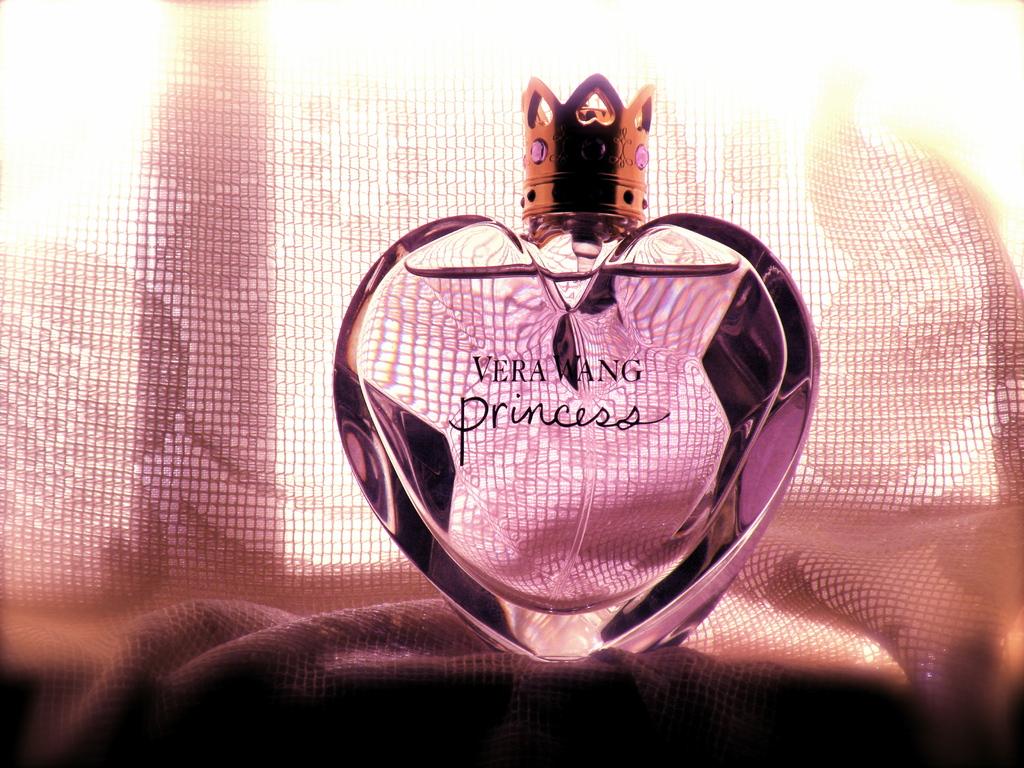What kind of perfume is this?
Offer a terse response. Vera wang princess. Who made the perfume?
Your answer should be compact. Vera wang. 